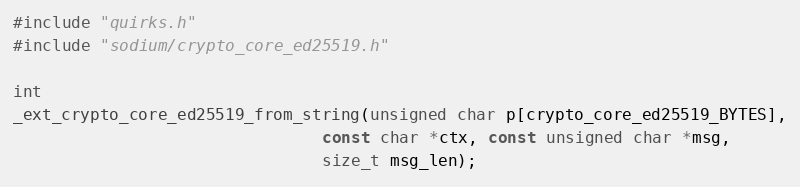<code> <loc_0><loc_0><loc_500><loc_500><_C_>#include "quirks.h"
#include "sodium/crypto_core_ed25519.h"

int
_ext_crypto_core_ed25519_from_string(unsigned char p[crypto_core_ed25519_BYTES],
                                const char *ctx, const unsigned char *msg,
                                size_t msg_len);
</code> 